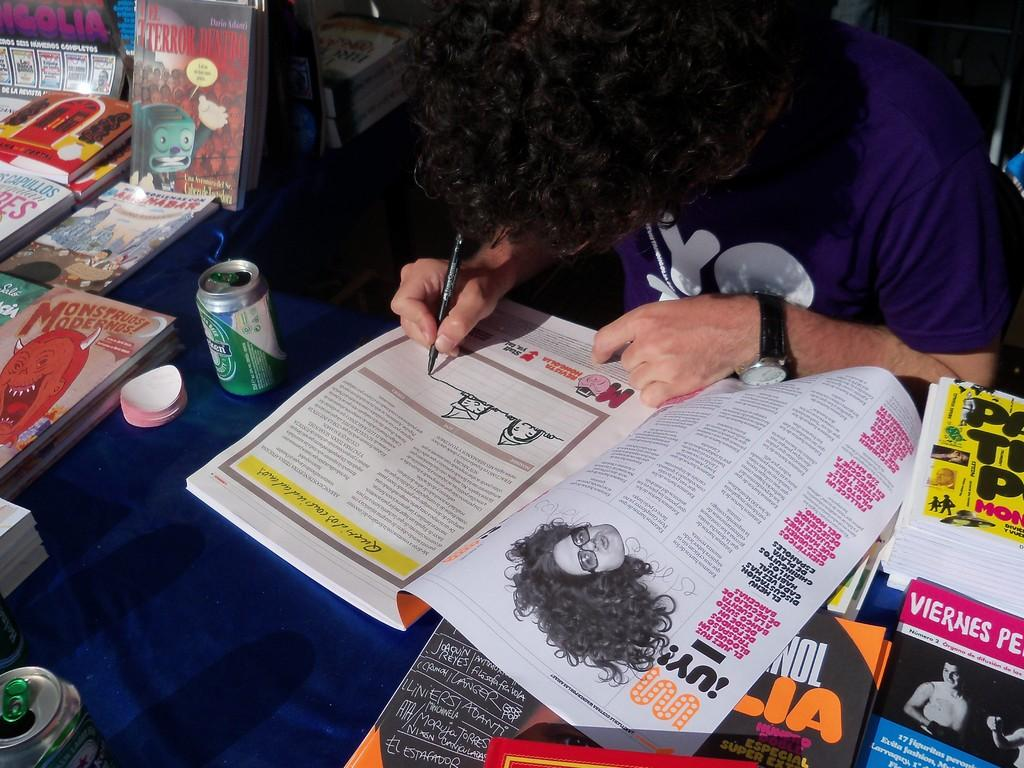What items can be seen on the table in the image? There are books, a tin, and other objects on the table in the image. What is the person in the image doing? The person is sitting and drawing on a book. What is the person holding in the image? The person is holding a pen. What type of key is being used to draw on the book in the image? There is no key present in the image; the person is using a pen to draw on the book. What room is the person sitting in while drawing on the book? The image does not provide information about the room or location where the person is sitting. 